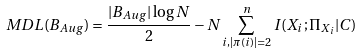<formula> <loc_0><loc_0><loc_500><loc_500>M D L ( B _ { A u g } ) = \frac { | B _ { A u g } | \log { N } } { 2 } - N \sum _ { i , | \pi ( i ) | = 2 } ^ { n } I ( X _ { i } ; \Pi _ { X _ { i } } | C )</formula> 